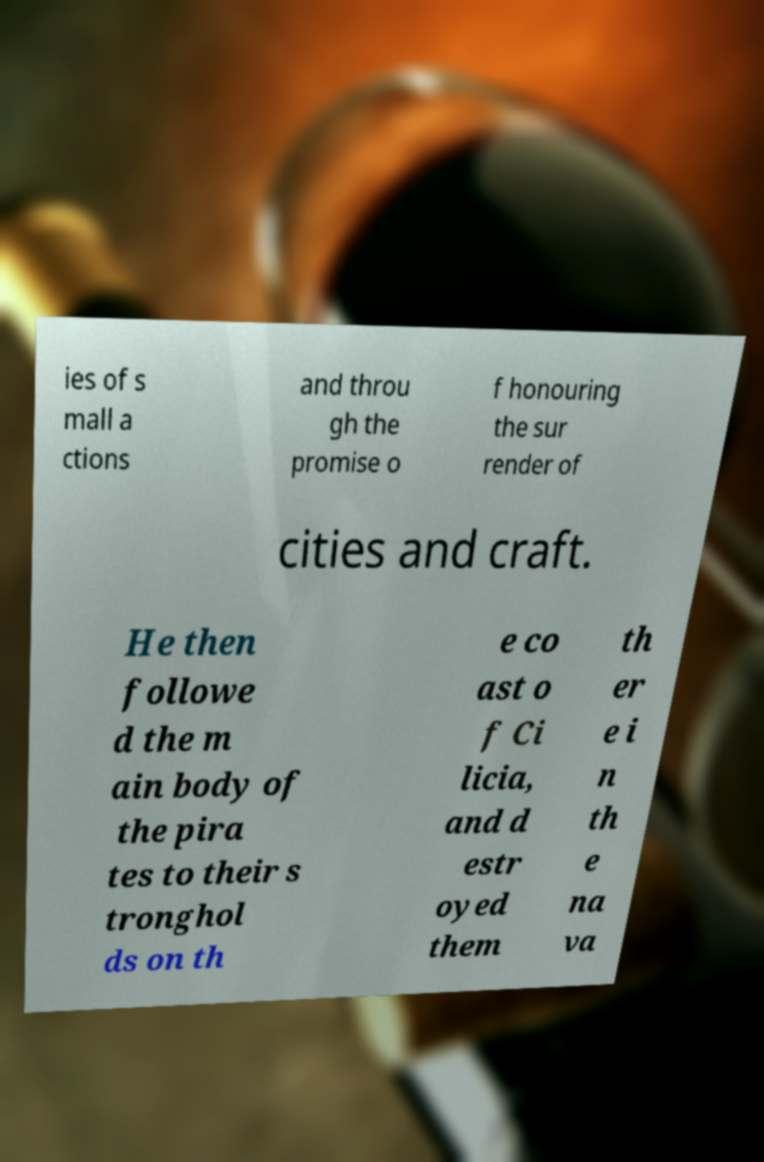Can you read and provide the text displayed in the image?This photo seems to have some interesting text. Can you extract and type it out for me? ies of s mall a ctions and throu gh the promise o f honouring the sur render of cities and craft. He then followe d the m ain body of the pira tes to their s tronghol ds on th e co ast o f Ci licia, and d estr oyed them th er e i n th e na va 